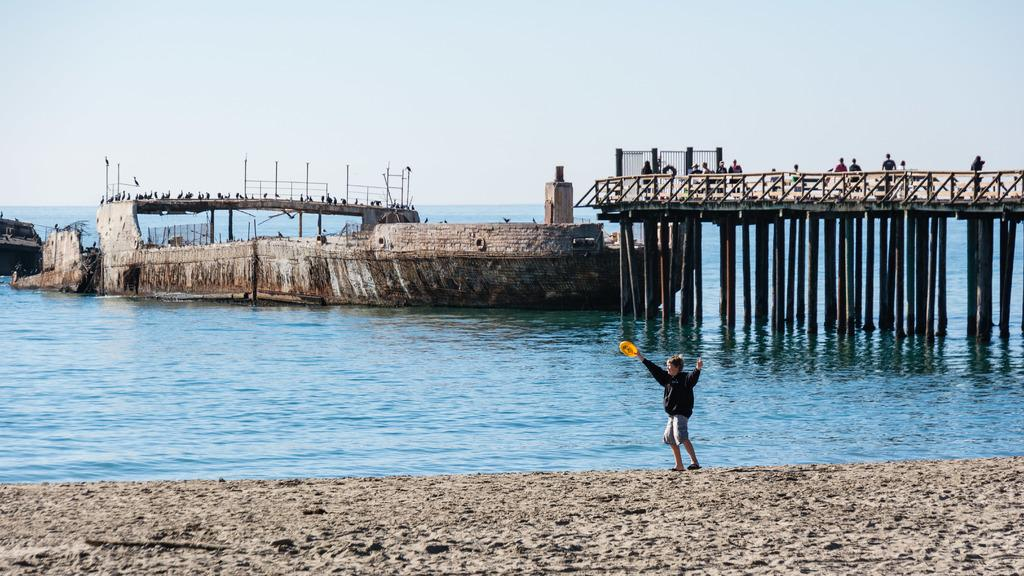Who or what can be seen in the image? There are people in the image. What structure is present in the image? There is a bridge in the image. What animals are visible in the image? There are birds in the image. What type of objects can be seen in the image? There are poles in the image. What color is the grey object in the image? The grey color object in the image is not specified, so we cannot determine its exact color. What is the color of the sky in the image? The sky is blue and white in color. What does the mouth of the bridge look like in the image? There is no mention of a mouth in the description of the bridge, and bridges do not have mouths. 